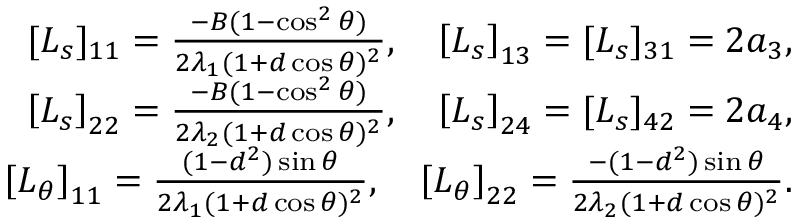<formula> <loc_0><loc_0><loc_500><loc_500>\begin{array} { r } { [ L _ { s } ] _ { 1 1 } = \frac { - B ( 1 - \cos ^ { 2 } \theta ) } { 2 \lambda _ { 1 } ( 1 + d \cos \theta ) ^ { 2 } } , \quad \left [ L _ { s } \right ] _ { 1 3 } = [ L _ { s } ] _ { 3 1 } = 2 a _ { 3 } , } \\ { \left [ L _ { s } \right ] _ { 2 2 } = \frac { - B ( 1 - \cos ^ { 2 } \theta ) } { 2 \lambda _ { 2 } ( 1 + d \cos \theta ) ^ { 2 } } , \quad \left [ L _ { s } \right ] _ { 2 4 } = [ L _ { s } ] _ { 4 2 } = 2 a _ { 4 } , } \\ { \left [ L _ { \theta } \right ] _ { 1 1 } = \frac { ( 1 - d ^ { 2 } ) \sin \theta } { 2 \lambda _ { 1 } ( 1 + d \cos \theta ) ^ { 2 } } , \quad \left [ L _ { \theta } \right ] _ { 2 2 } = \frac { - ( 1 - d ^ { 2 } ) \sin \theta } { 2 \lambda _ { 2 } ( 1 + d \cos \theta ) ^ { 2 } } . } \end{array}</formula> 